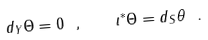Convert formula to latex. <formula><loc_0><loc_0><loc_500><loc_500>d _ { Y } \Theta = 0 \ , \quad \iota ^ { \ast } \Theta = d _ { S } \theta \ .</formula> 